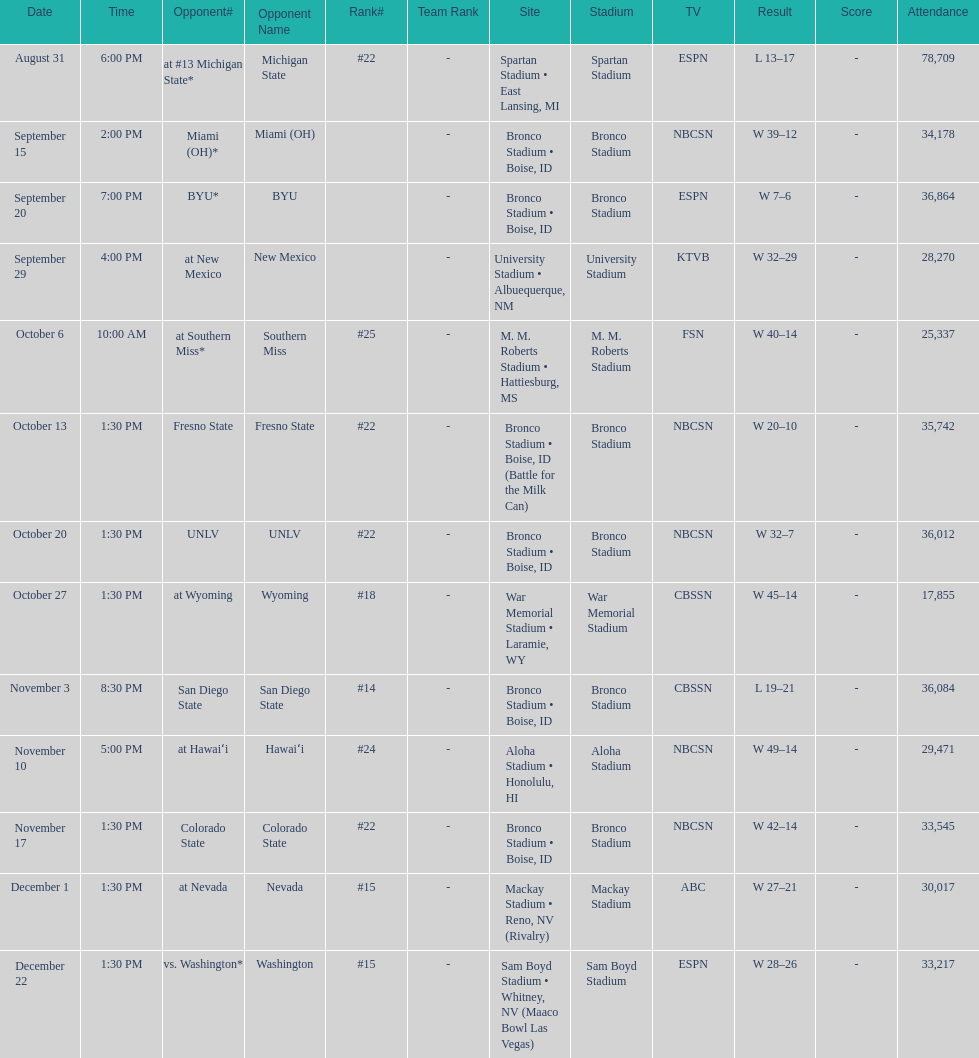What was the most consecutive wins for the team shown in the season? 7. 